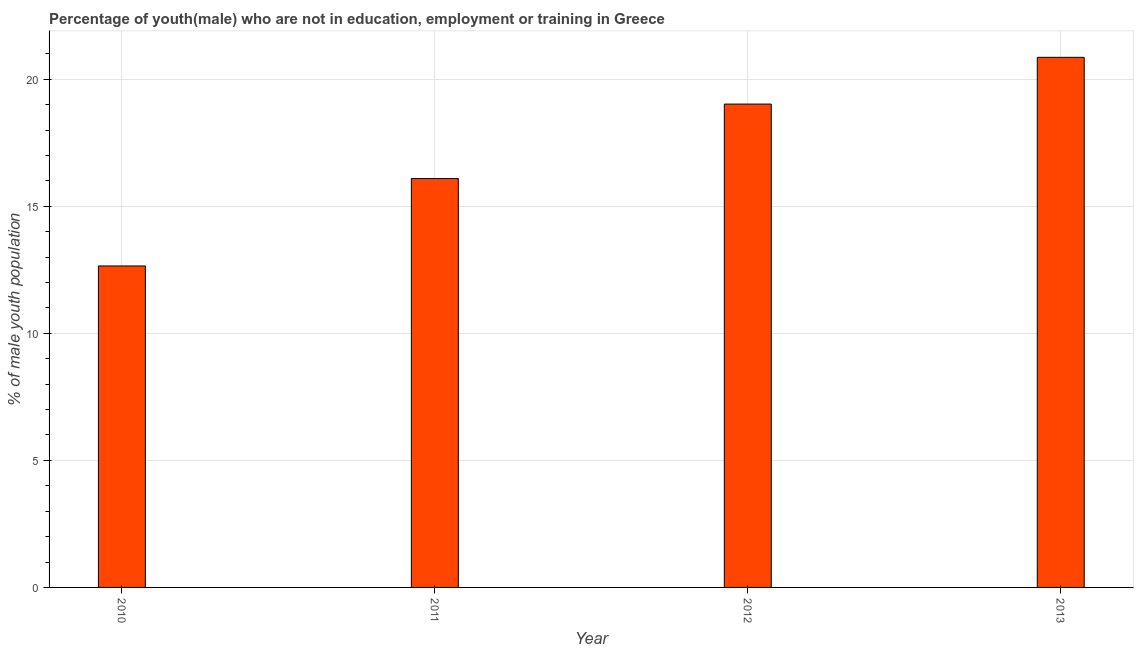What is the title of the graph?
Ensure brevity in your answer.  Percentage of youth(male) who are not in education, employment or training in Greece. What is the label or title of the X-axis?
Make the answer very short. Year. What is the label or title of the Y-axis?
Ensure brevity in your answer.  % of male youth population. What is the unemployed male youth population in 2011?
Ensure brevity in your answer.  16.09. Across all years, what is the maximum unemployed male youth population?
Offer a very short reply. 20.86. Across all years, what is the minimum unemployed male youth population?
Provide a short and direct response. 12.65. What is the sum of the unemployed male youth population?
Provide a succinct answer. 68.62. What is the difference between the unemployed male youth population in 2010 and 2013?
Offer a terse response. -8.21. What is the average unemployed male youth population per year?
Your answer should be compact. 17.16. What is the median unemployed male youth population?
Give a very brief answer. 17.56. Do a majority of the years between 2013 and 2012 (inclusive) have unemployed male youth population greater than 2 %?
Keep it short and to the point. No. What is the ratio of the unemployed male youth population in 2012 to that in 2013?
Your response must be concise. 0.91. Is the unemployed male youth population in 2010 less than that in 2011?
Ensure brevity in your answer.  Yes. What is the difference between the highest and the second highest unemployed male youth population?
Ensure brevity in your answer.  1.84. What is the difference between the highest and the lowest unemployed male youth population?
Keep it short and to the point. 8.21. In how many years, is the unemployed male youth population greater than the average unemployed male youth population taken over all years?
Your response must be concise. 2. How many bars are there?
Provide a short and direct response. 4. Are all the bars in the graph horizontal?
Provide a short and direct response. No. How many years are there in the graph?
Provide a succinct answer. 4. What is the % of male youth population in 2010?
Ensure brevity in your answer.  12.65. What is the % of male youth population in 2011?
Offer a terse response. 16.09. What is the % of male youth population of 2012?
Your answer should be compact. 19.02. What is the % of male youth population of 2013?
Give a very brief answer. 20.86. What is the difference between the % of male youth population in 2010 and 2011?
Ensure brevity in your answer.  -3.44. What is the difference between the % of male youth population in 2010 and 2012?
Make the answer very short. -6.37. What is the difference between the % of male youth population in 2010 and 2013?
Ensure brevity in your answer.  -8.21. What is the difference between the % of male youth population in 2011 and 2012?
Make the answer very short. -2.93. What is the difference between the % of male youth population in 2011 and 2013?
Provide a succinct answer. -4.77. What is the difference between the % of male youth population in 2012 and 2013?
Offer a very short reply. -1.84. What is the ratio of the % of male youth population in 2010 to that in 2011?
Provide a succinct answer. 0.79. What is the ratio of the % of male youth population in 2010 to that in 2012?
Give a very brief answer. 0.67. What is the ratio of the % of male youth population in 2010 to that in 2013?
Give a very brief answer. 0.61. What is the ratio of the % of male youth population in 2011 to that in 2012?
Your answer should be compact. 0.85. What is the ratio of the % of male youth population in 2011 to that in 2013?
Provide a succinct answer. 0.77. What is the ratio of the % of male youth population in 2012 to that in 2013?
Ensure brevity in your answer.  0.91. 